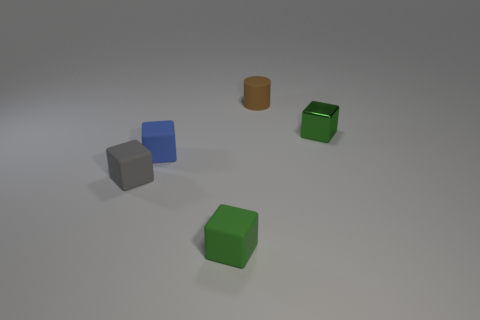What shapes can be seen in the image? In the image, there are three cube-shaped objects and one cylinder-shaped object. The cubes are green, blue, and gray, while the cylinder has a brown or orange hue. 